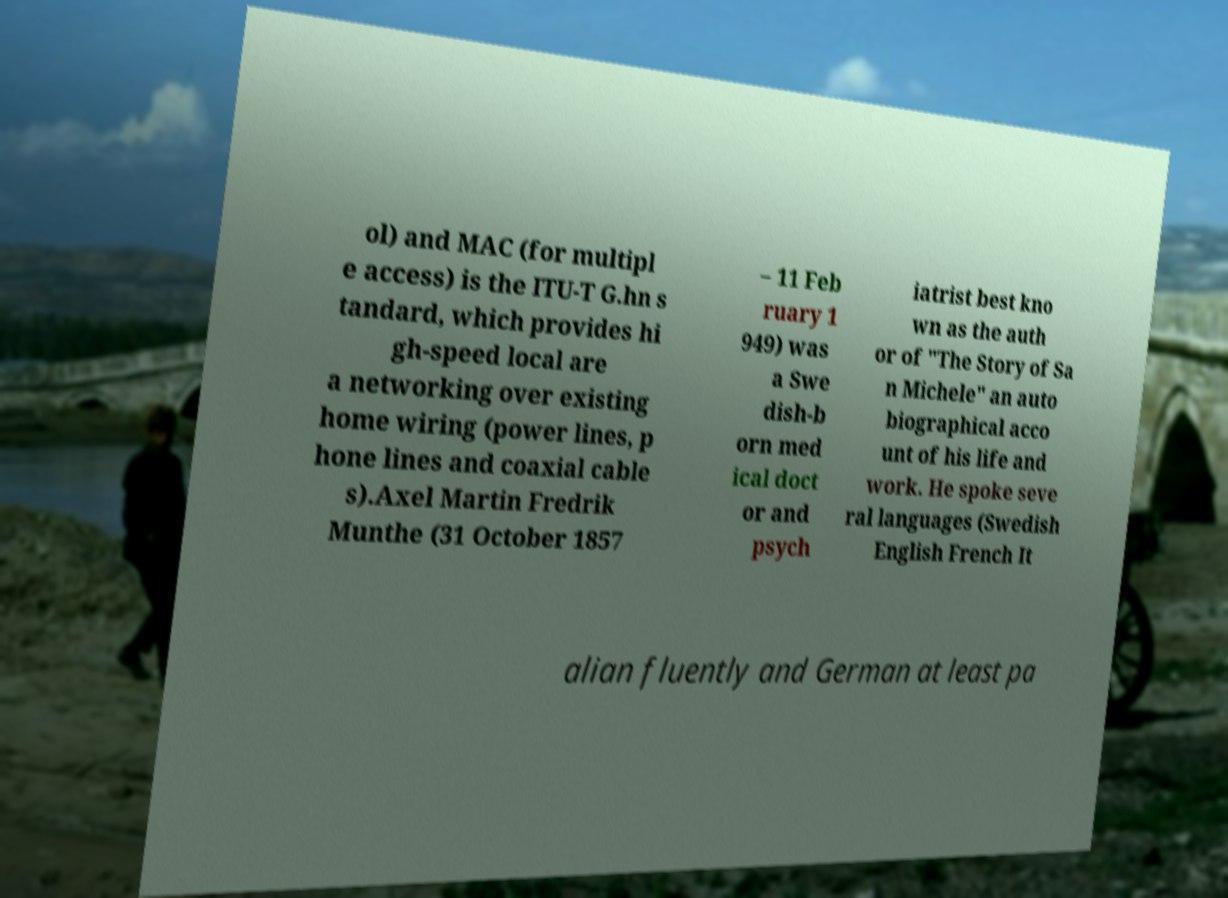There's text embedded in this image that I need extracted. Can you transcribe it verbatim? ol) and MAC (for multipl e access) is the ITU-T G.hn s tandard, which provides hi gh-speed local are a networking over existing home wiring (power lines, p hone lines and coaxial cable s).Axel Martin Fredrik Munthe (31 October 1857 – 11 Feb ruary 1 949) was a Swe dish-b orn med ical doct or and psych iatrist best kno wn as the auth or of "The Story of Sa n Michele" an auto biographical acco unt of his life and work. He spoke seve ral languages (Swedish English French It alian fluently and German at least pa 